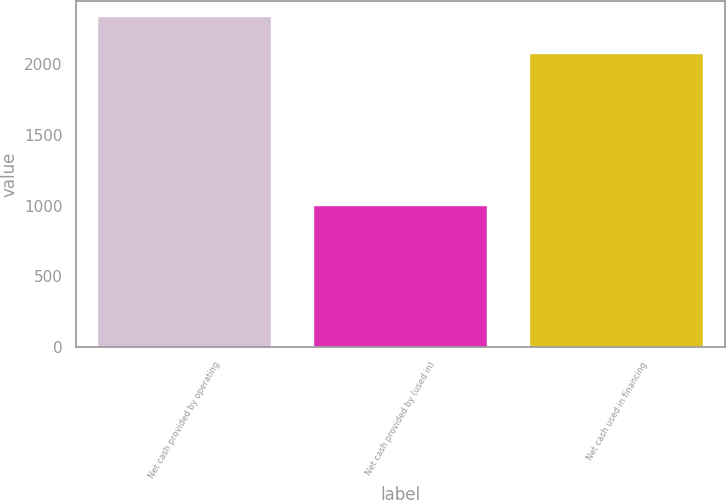Convert chart to OTSL. <chart><loc_0><loc_0><loc_500><loc_500><bar_chart><fcel>Net cash provided by operating<fcel>Net cash provided by (used in)<fcel>Net cash used in financing<nl><fcel>2331<fcel>995<fcel>2072<nl></chart> 